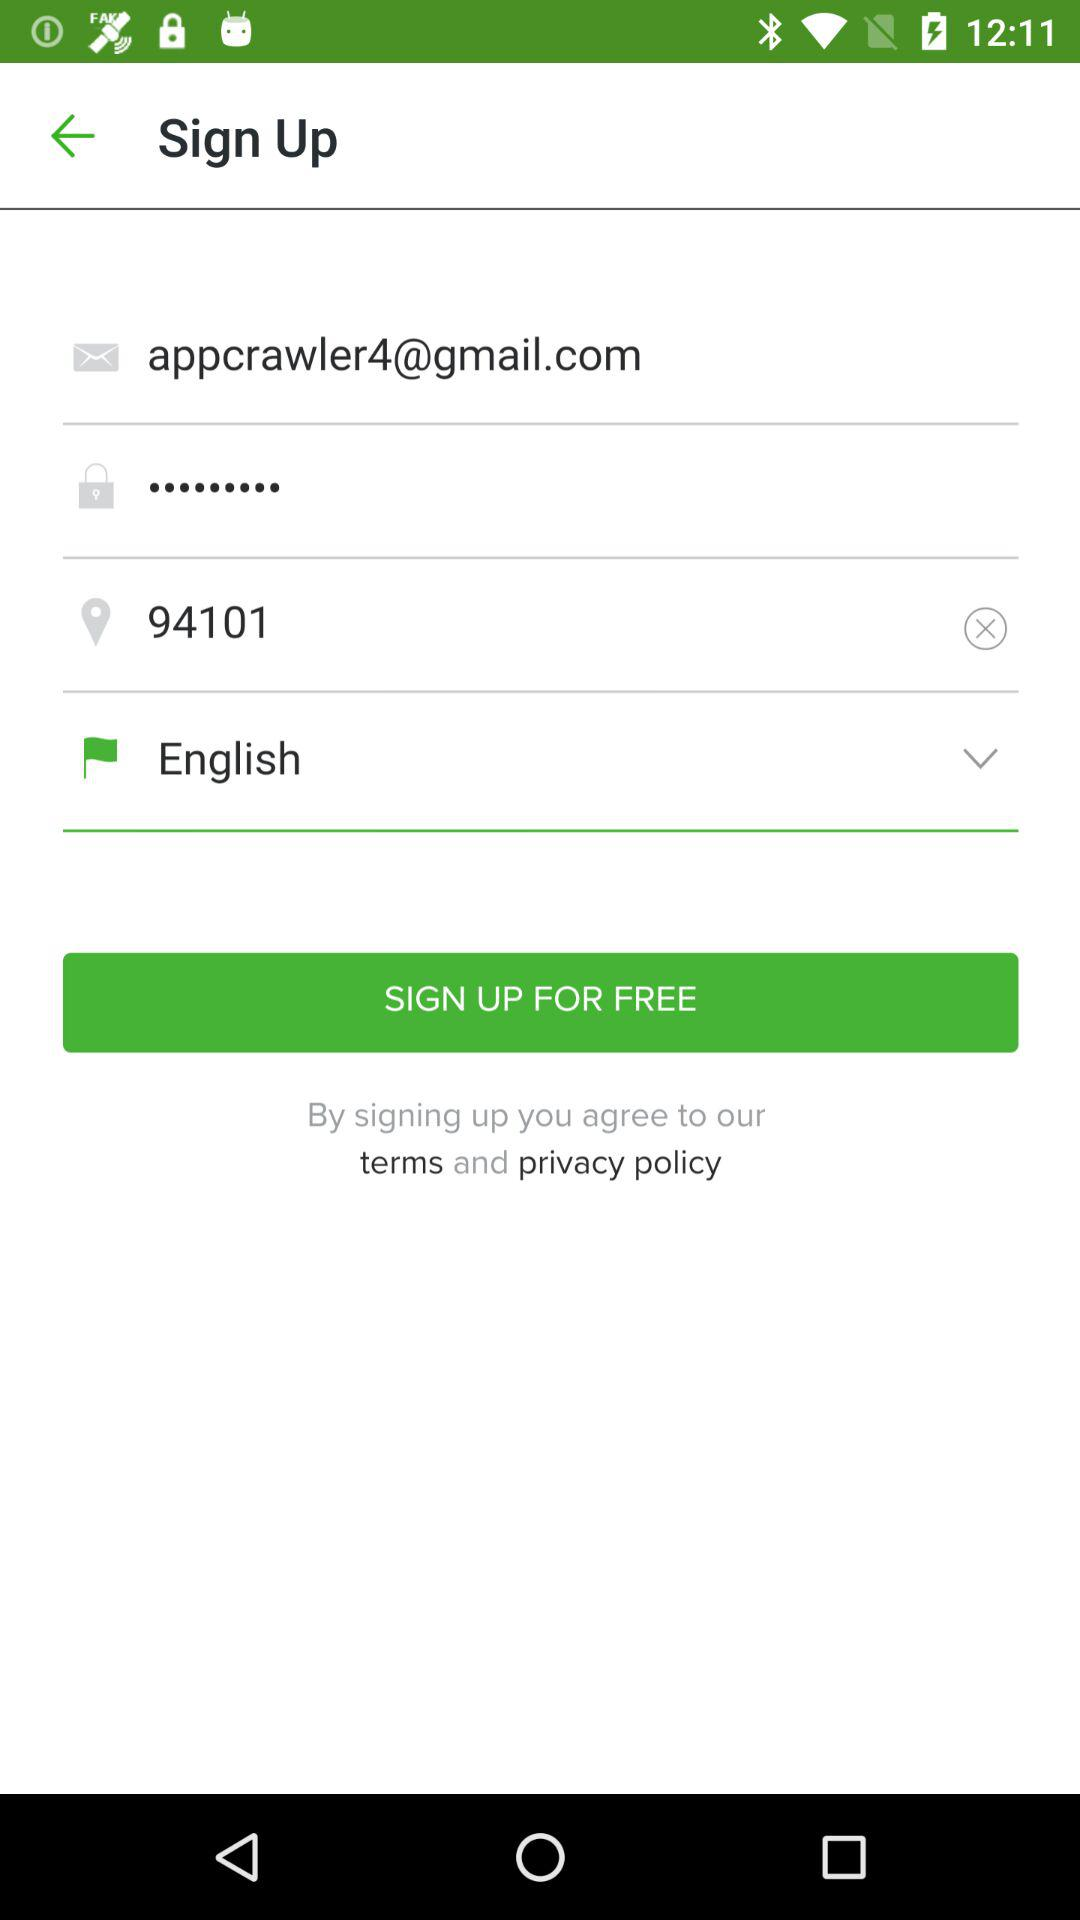What are the sign-up charges? The sign-up charges are free. 